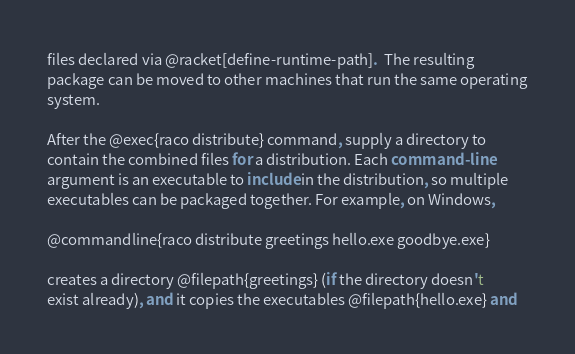Convert code to text. <code><loc_0><loc_0><loc_500><loc_500><_Racket_>files declared via @racket[define-runtime-path].  The resulting
package can be moved to other machines that run the same operating
system.

After the @exec{raco distribute} command, supply a directory to
contain the combined files for a distribution. Each command-line
argument is an executable to include in the distribution, so multiple
executables can be packaged together. For example, on Windows,

@commandline{raco distribute greetings hello.exe goodbye.exe}

creates a directory @filepath{greetings} (if the directory doesn't
exist already), and it copies the executables @filepath{hello.exe} and</code> 